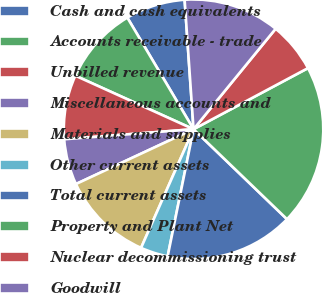Convert chart. <chart><loc_0><loc_0><loc_500><loc_500><pie_chart><fcel>Cash and cash equivalents<fcel>Accounts receivable - trade<fcel>Unbilled revenue<fcel>Miscellaneous accounts and<fcel>Materials and supplies<fcel>Other current assets<fcel>Total current assets<fcel>Property and Plant Net<fcel>Nuclear decommissioning trust<fcel>Goodwill<nl><fcel>7.43%<fcel>9.71%<fcel>8.0%<fcel>5.71%<fcel>11.43%<fcel>3.43%<fcel>16.0%<fcel>20.0%<fcel>6.29%<fcel>12.0%<nl></chart> 